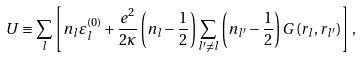<formula> <loc_0><loc_0><loc_500><loc_500>U \equiv \sum _ { l } \left [ n _ { l } \varepsilon ^ { \left ( 0 \right ) } _ { l } + \frac { e ^ { 2 } } { 2 \kappa } \left ( n _ { l } - \frac { 1 } { 2 } \right ) \sum _ { l ^ { \prime } \neq l } \left ( n _ { l ^ { \prime } } - \frac { 1 } { 2 } \right ) G \left ( r _ { l } , r _ { l ^ { \prime } } \right ) \right ] ,</formula> 